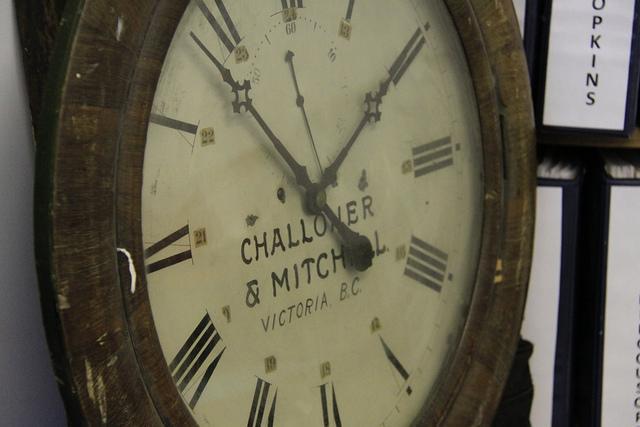How many books are there?
Give a very brief answer. 2. How many clocks are there?
Give a very brief answer. 1. How many people in this picture are wearing blue hats?
Give a very brief answer. 0. 